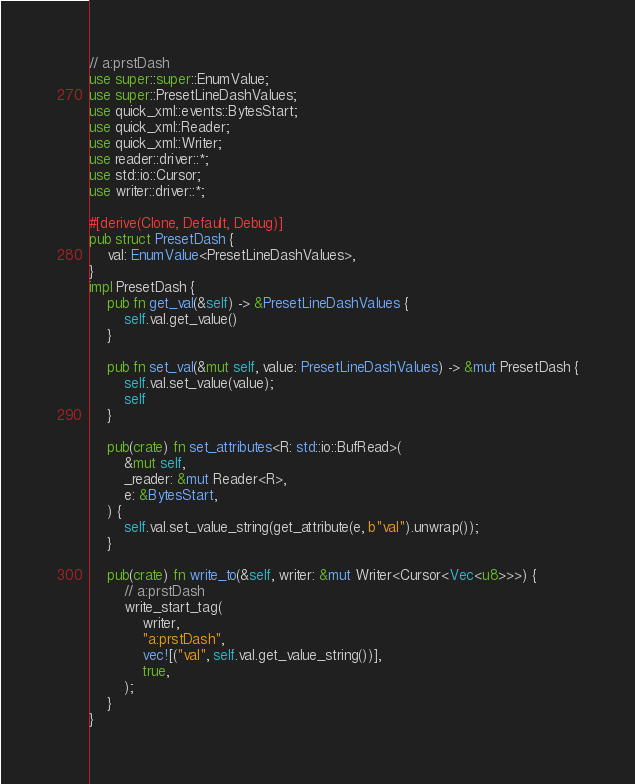<code> <loc_0><loc_0><loc_500><loc_500><_Rust_>// a:prstDash
use super::super::EnumValue;
use super::PresetLineDashValues;
use quick_xml::events::BytesStart;
use quick_xml::Reader;
use quick_xml::Writer;
use reader::driver::*;
use std::io::Cursor;
use writer::driver::*;

#[derive(Clone, Default, Debug)]
pub struct PresetDash {
    val: EnumValue<PresetLineDashValues>,
}
impl PresetDash {
    pub fn get_val(&self) -> &PresetLineDashValues {
        self.val.get_value()
    }

    pub fn set_val(&mut self, value: PresetLineDashValues) -> &mut PresetDash {
        self.val.set_value(value);
        self
    }

    pub(crate) fn set_attributes<R: std::io::BufRead>(
        &mut self,
        _reader: &mut Reader<R>,
        e: &BytesStart,
    ) {
        self.val.set_value_string(get_attribute(e, b"val").unwrap());
    }

    pub(crate) fn write_to(&self, writer: &mut Writer<Cursor<Vec<u8>>>) {
        // a:prstDash
        write_start_tag(
            writer,
            "a:prstDash",
            vec![("val", self.val.get_value_string())],
            true,
        );
    }
}
</code> 